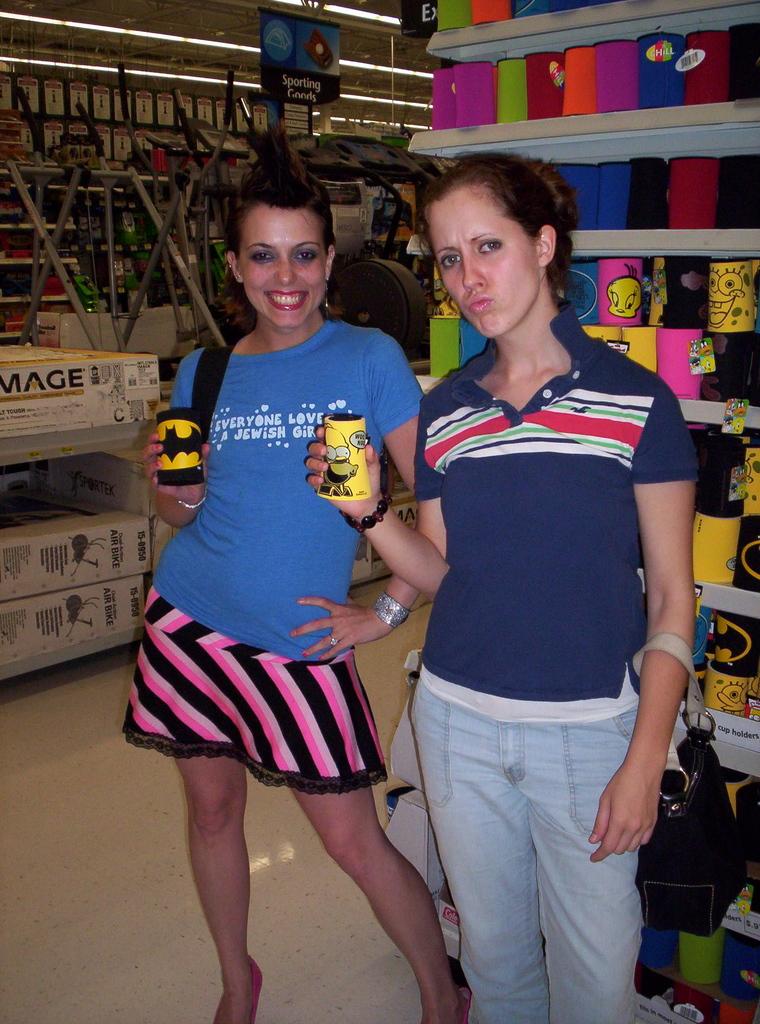Everyone loves a what girl?
Offer a very short reply. Jewish. 